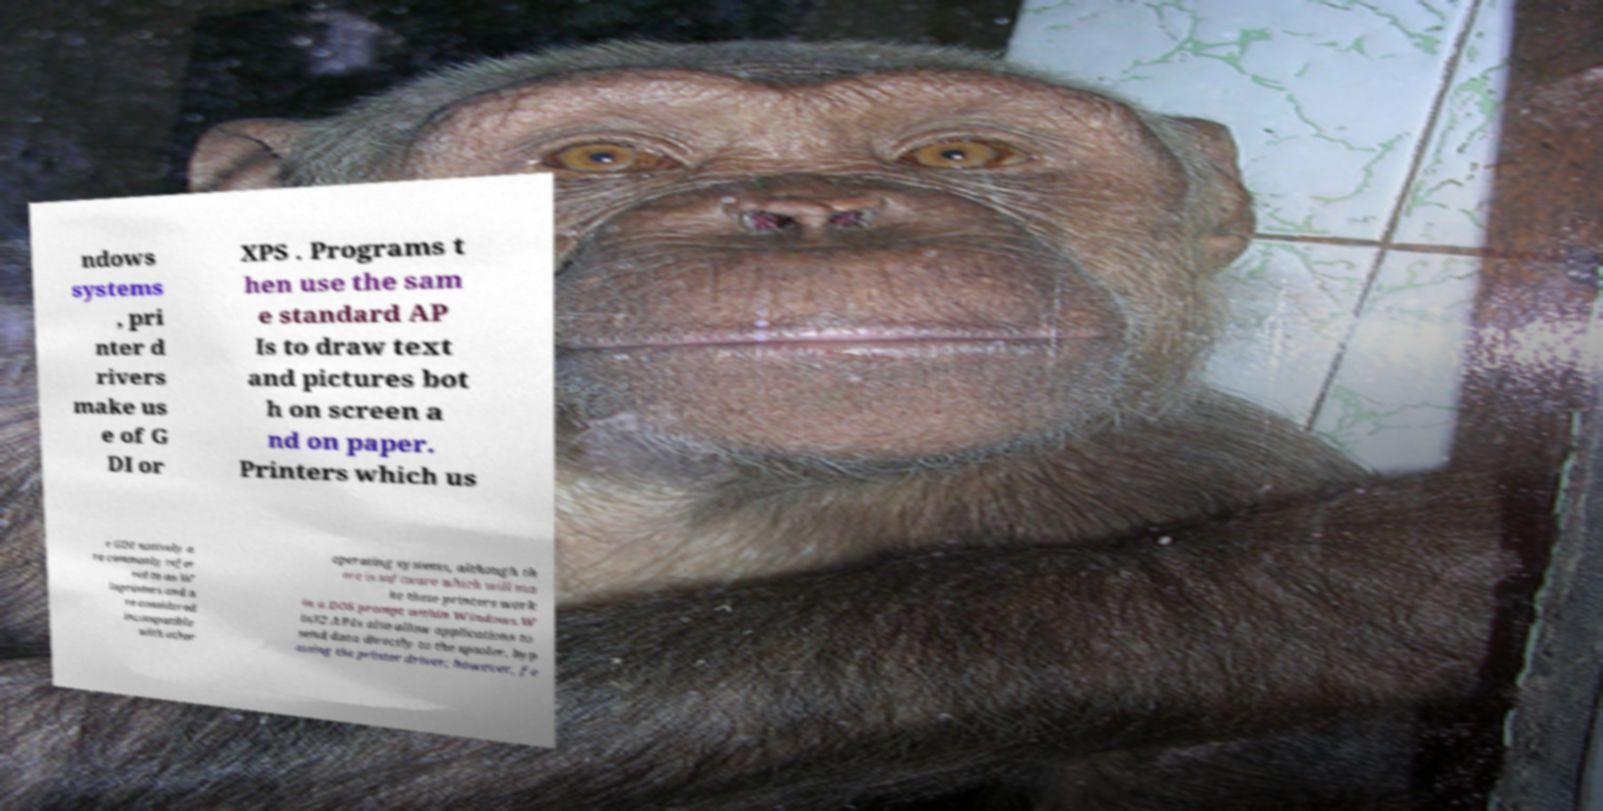There's text embedded in this image that I need extracted. Can you transcribe it verbatim? ndows systems , pri nter d rivers make us e of G DI or XPS . Programs t hen use the sam e standard AP Is to draw text and pictures bot h on screen a nd on paper. Printers which us e GDI natively a re commonly refer red to as W inprinters and a re considered incompatible with other operating systems, although th ere is software which will ma ke these printers work in a DOS prompt within Windows.W in32 APIs also allow applications to send data directly to the spooler, byp assing the printer driver; however, fe 